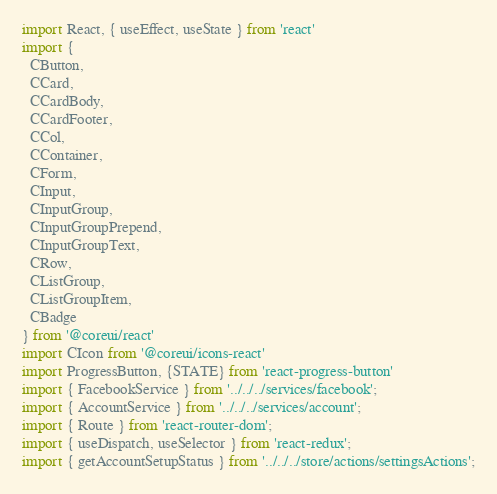<code> <loc_0><loc_0><loc_500><loc_500><_JavaScript_>import React, { useEffect, useState } from 'react'
import {
  CButton,
  CCard,
  CCardBody,
  CCardFooter,
  CCol,
  CContainer,
  CForm,
  CInput,
  CInputGroup,
  CInputGroupPrepend,
  CInputGroupText,
  CRow,
  CListGroup,
  CListGroupItem,
  CBadge
} from '@coreui/react'
import CIcon from '@coreui/icons-react'
import ProgressButton, {STATE} from 'react-progress-button'
import { FacebookService } from '../../../services/facebook';
import { AccountService } from '../../../services/account';
import { Route } from 'react-router-dom';
import { useDispatch, useSelector } from 'react-redux';
import { getAccountSetupStatus } from '../../../store/actions/settingsActions';
</code> 